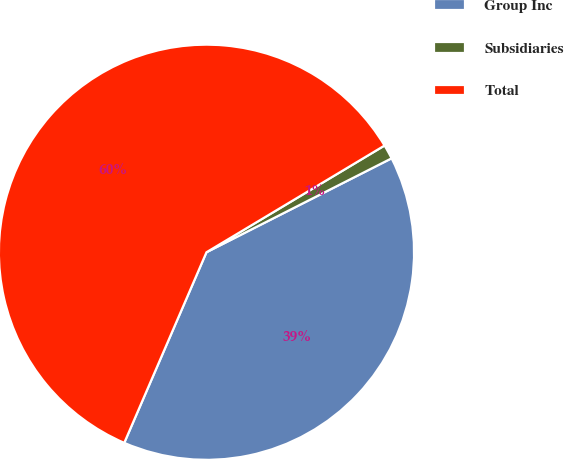Convert chart. <chart><loc_0><loc_0><loc_500><loc_500><pie_chart><fcel>Group Inc<fcel>Subsidiaries<fcel>Total<nl><fcel>38.95%<fcel>1.12%<fcel>59.92%<nl></chart> 